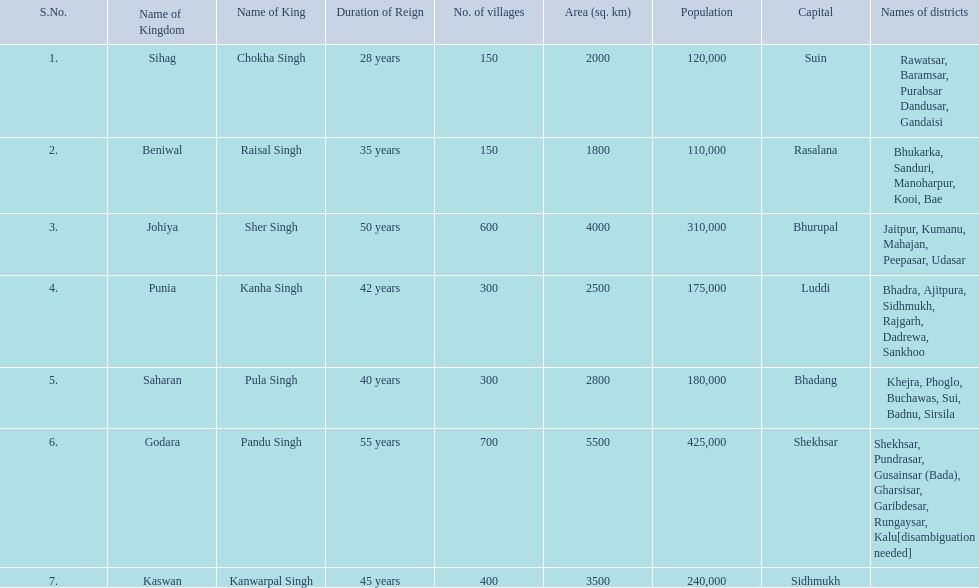What is the most amount of villages in a kingdom? 700. What is the second most amount of villages in a kingdom? 600. What kingdom has 600 villages? Johiya. 